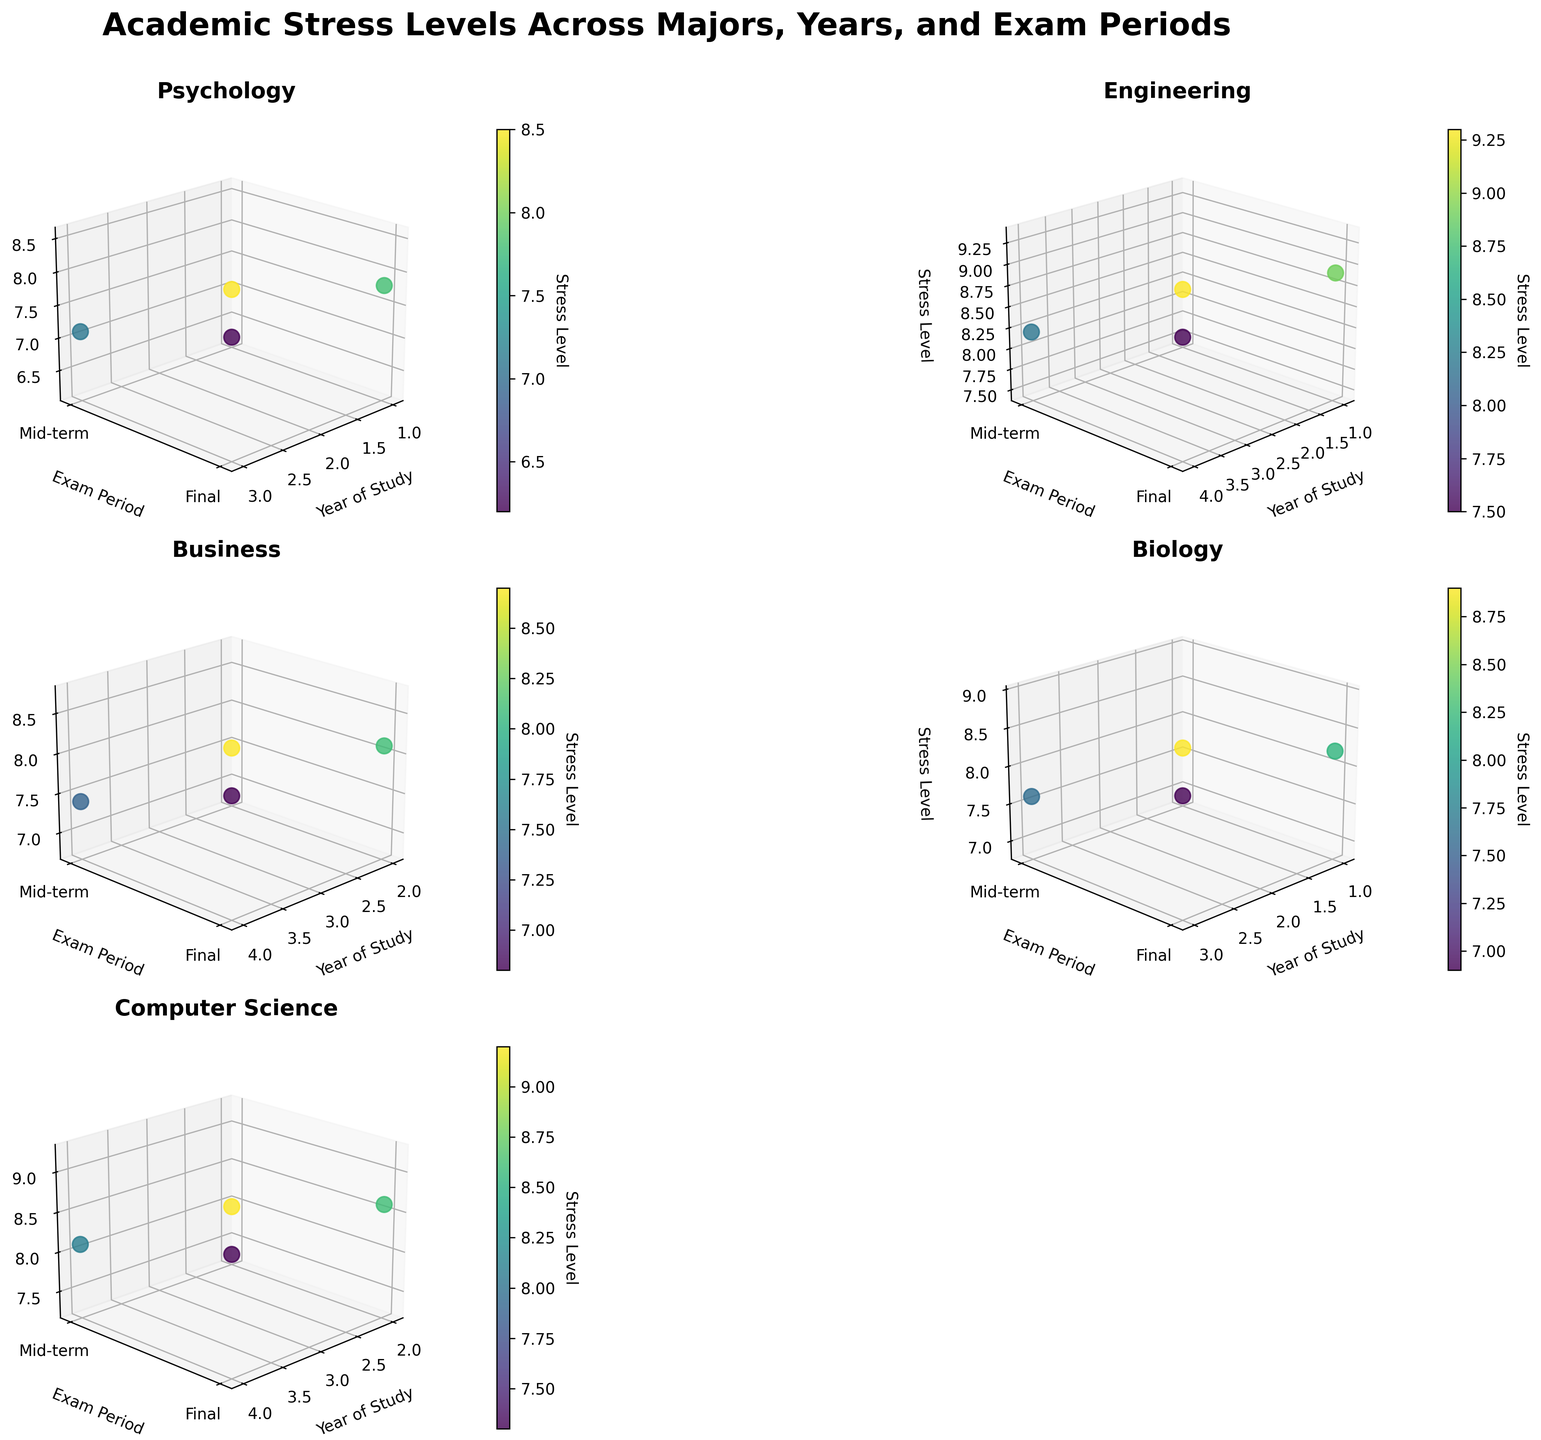what majors are included in the figure? The title of the chart mentions "majors," and each subplot is titled with different majors, indicating the presence of multiple majors. From the x-axis labels in the subplots, there are six majors: Psychology, Engineering, Business, Biology, and Computer Science.
Answer: Psychology, Engineering, Business, Biology, and Computer Science What is the stress level during mid-terms for 1st-year Psychology students? Looking at the subplot for Psychology and identifying the point corresponding to "Mid-term" on the y-axis and "1" on the x-axis, the stress level is clearly shown.
Answer: 6.2 Which major displays the highest stress level during finals? Observing the z-axis (Stress Level) across all subplots and focusing on the data points corresponding to 'Finals' on the y-axis, the highest value appears in the Engineering subplot. The 4th-year student during finals has the highest stress level.
Answer: Engineering What's the difference in stress levels between mid-terms and finals for 2nd-year Business students? In the Business subplot, locate the 2nd-year data points and compare the stress levels for 'Mid-term' and 'Finals'. The mid-term stress level is 6.8, and the final stress level is 8.1. The difference can be calculated as 8.1 - 6.8.
Answer: 1.3 Which year of Biology students experience the highest stress level during mid-terms? In the Biology subplot, observe the data points along the x-axis (Year of Study) with y-axis at 'Mid-term'. The highest stress level among the mid-term points is for the 3rd-year students.
Answer: Year 3 What is the average stress level for 4th-year students across all majors during finals? For each major's subplot, identify the stress levels for 4th-year students during finals. The values are: Engineering (9.3), Business (8.7), Computer Science (9.2). Adding these values: 9.3 + 8.7 + 9.2 = 27.2, and then dividing by the number of majors (3), it gives the average stress level as 27.2 / 3.
Answer: 9.07 Do 1st-year Engineering students exhibit higher stress levels during mid-terms compared to 2nd-year Business students? Comparing the stress levels from the Engineering subplot for 1st-year students during mid-terms (7.5) to the Business subplot for 2nd-year students during mid-terms (6.8), the stress level for 1st-year Engineering students is higher.
Answer: Yes How does the stress level trend from mid-terms to finals for Psychology students over the years? Observing the Psychology subplot, check the stress levels for both mid-terms and finals for each academic year. Generally, there is an increase from mid-terms to finals in all years, indicating a rising trend.
Answer: Increasing What's the overall pattern in stress levels for Computer Science students across different exam periods? The Computer Science subplot shows stress levels for mid-terms and finals. The stress levels rise from mid-terms to finals within the same year and also increase across the years.
Answer: Rises 